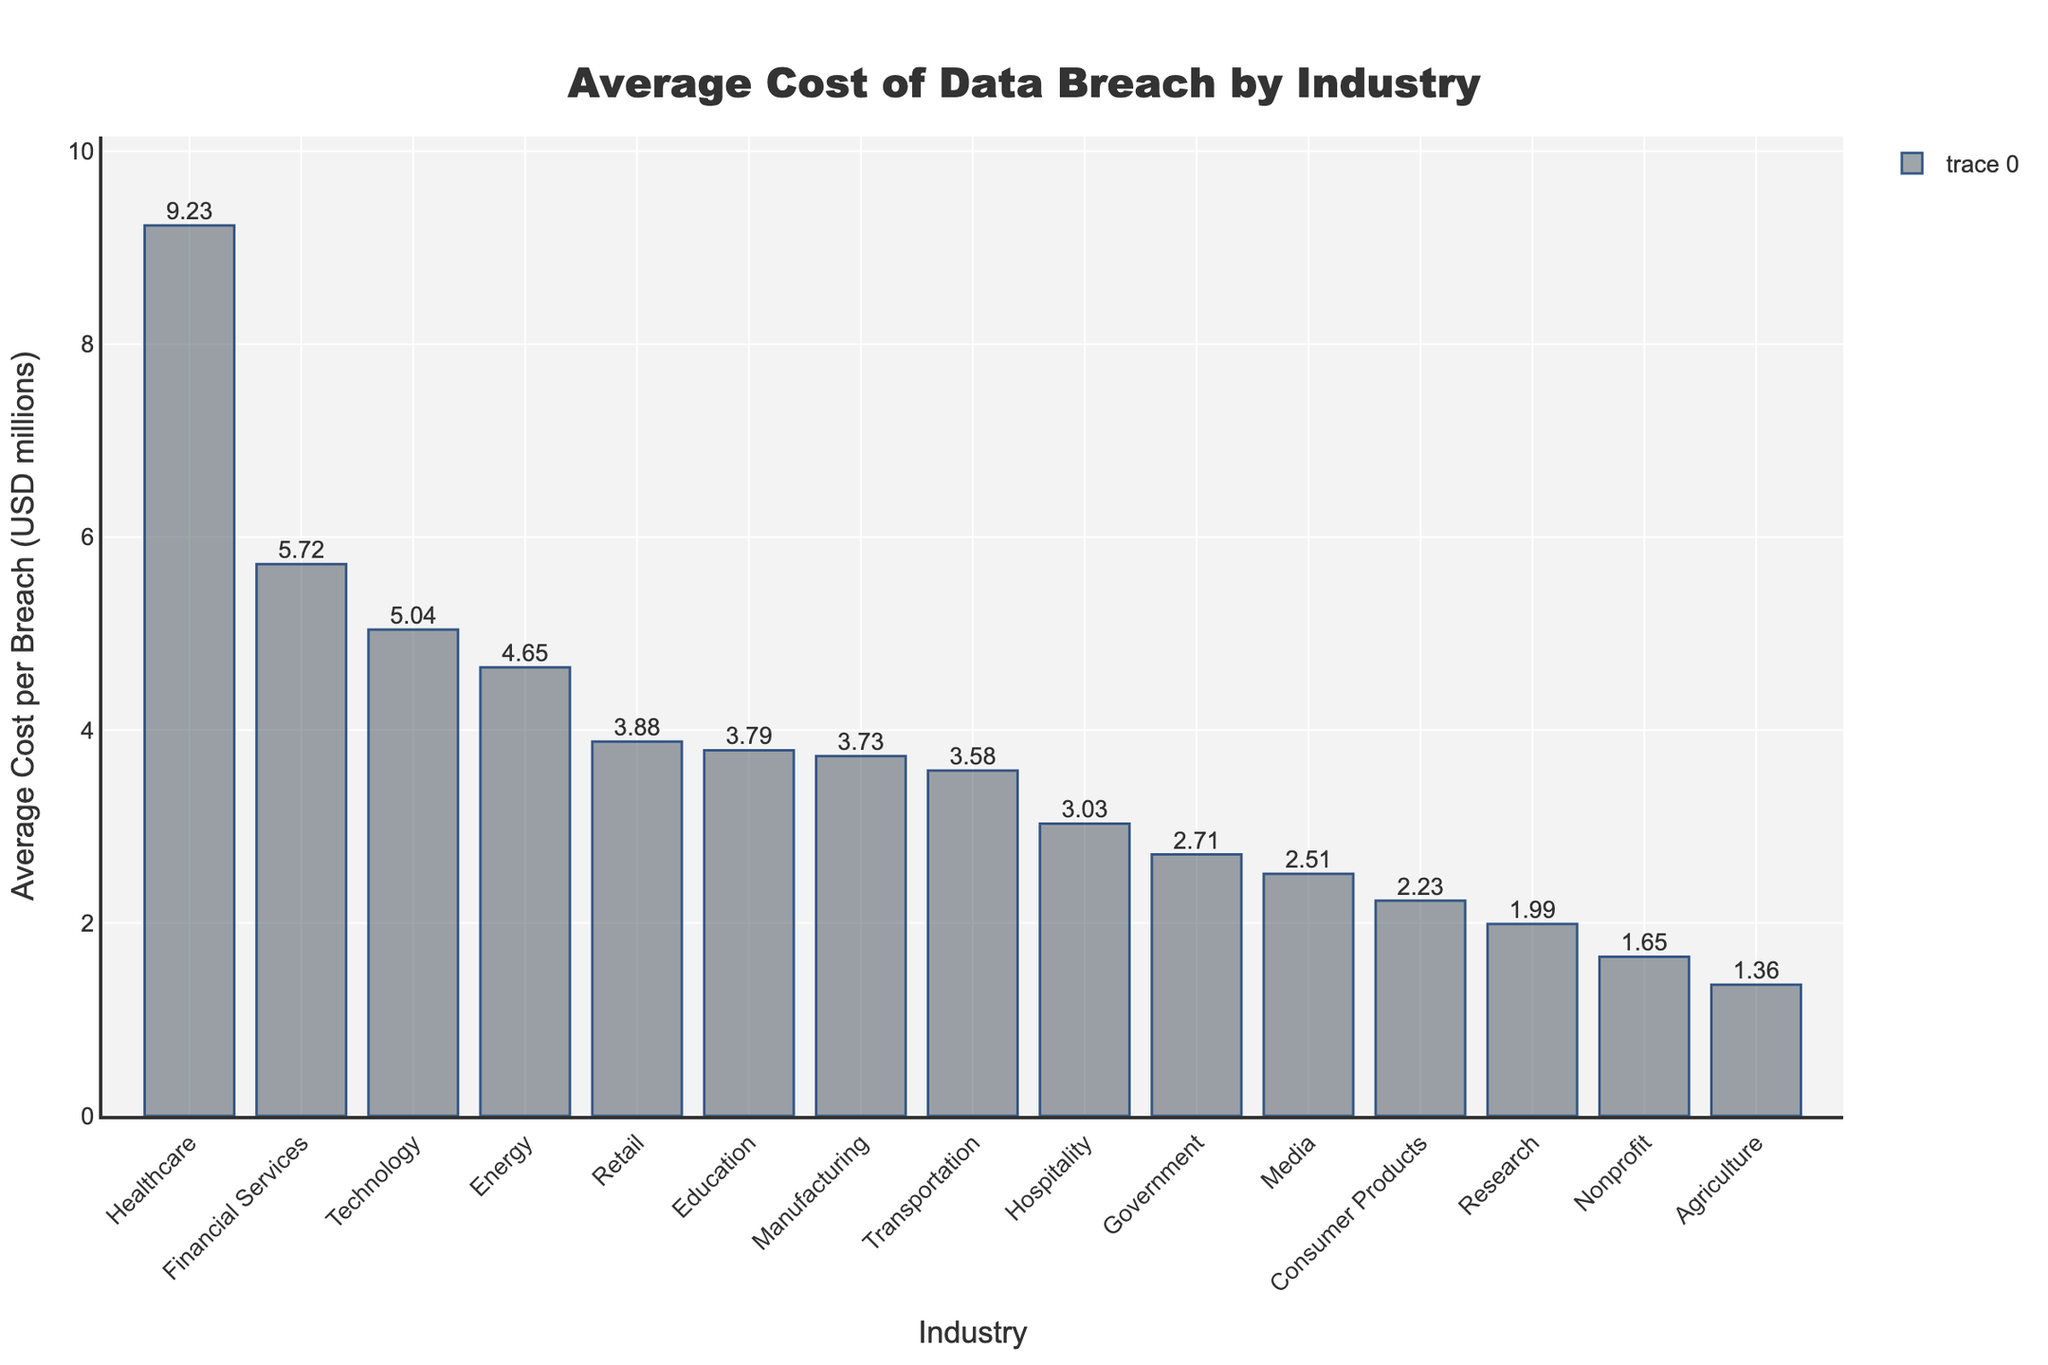What industry has the highest average cost per data breach? The highest bar represents the industry with the highest average cost per data breach. The bar for Healthcare is the tallest, indicating it has the highest cost.
Answer: Healthcare What is the difference in average cost per breach between the Financial Services and Government sectors? The bar for Financial Services reaches 5.72 million, and the bar for Government reaches 2.71 million. Subtract 2.71 from 5.72 to find the difference. 5.72 - 2.71 = 3.01 million.
Answer: 3.01 million Which industry sector has an average cost per breach closest to 4 million USD? Look for the bar whose height is closest to 4 million on the y-axis. The Retail bar at 3.88 million is the closest to 4 million.
Answer: Retail What is the combined average cost per breach for the Technology and Retail sectors? The bar for Technology reaches 5.04 million, and the bar for Retail reaches 3.88 million. Add these values together. 5.04 + 3.88 = 8.92 million.
Answer: 8.92 million Which industry sectors have an average cost per breach below 2 million USD? Identify the bars that do not reach the 2 million USD mark on the y-axis. Bars for Research, Nonprofit, and Agriculture are below 2 million.
Answer: Research, Nonprofit, Agriculture Compare the average costs per breach between the Technology and Energy sectors. Which one is higher? The bar for Technology reaches 5.04 million, and the bar for Energy reaches 4.65 million. 5.04 is greater than 4.65, so Technology is higher.
Answer: Technology What is the average cost per breach for the sector with the lowest cost? The shortest bar represents the industry with the lowest average cost per breach. The Agriculture bar is the shortest at 1.36 million.
Answer: 1.36 million How much higher is the average cost per breach in the Healthcare sector compared to the Media sector? The Healthcare sector has an average cost per breach of 9.23 million, while the Media sector has 2.51 million. Subtract 2.51 from 9.23 to find the difference. 9.23 - 2.51 = 6.72 million.
Answer: 6.72 million What is the range of average costs per breach among all listed industry sectors? The range is found by subtracting the smallest value from the largest value. The highest cost is Healthcare at 9.23 million, and the lowest is Agriculture at 1.36 million. 9.23 - 1.36 = 7.87 million.
Answer: 7.87 million 